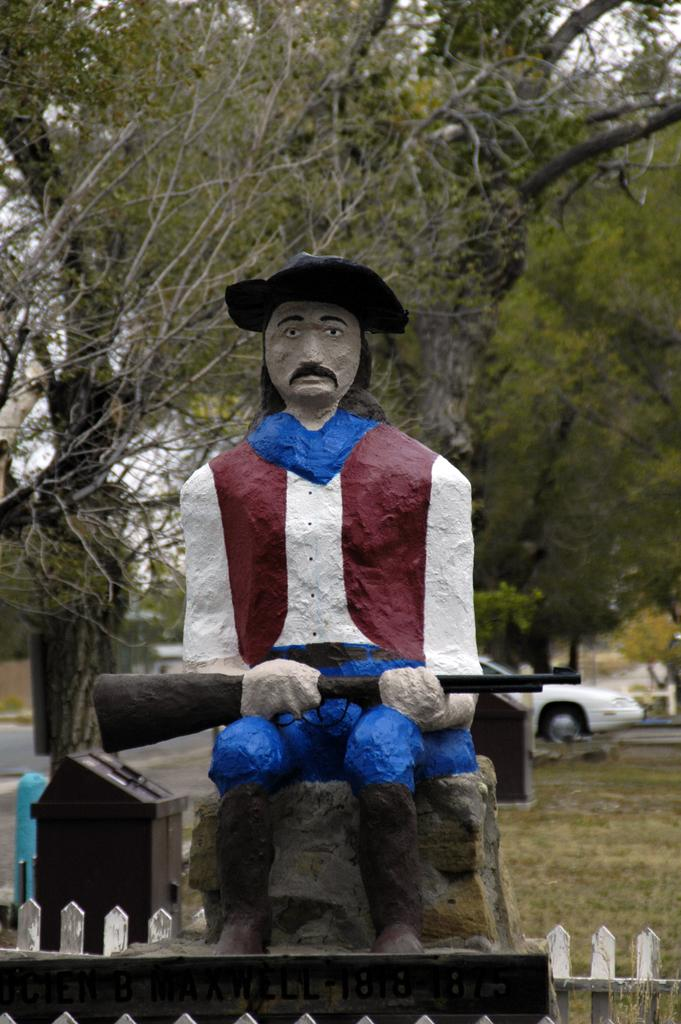What is the main subject in the center of the image? There is a statue in the center of the image. What can be seen in the background of the image? There are trees in the background of the image. What type of note is attached to the statue in the image? There is no note attached to the statue in the image. What material is the statue made of, such as brick or stone? The material of the statue is not mentioned in the provided facts, so it cannot be determined from the image. 